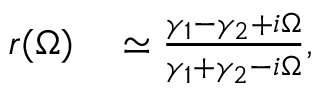Convert formula to latex. <formula><loc_0><loc_0><loc_500><loc_500>\begin{array} { r l } { r ( \Omega ) } & \simeq \frac { \gamma _ { 1 } - \gamma _ { 2 } + i \Omega } { \gamma _ { 1 } + \gamma _ { 2 } - i \Omega } , } \end{array}</formula> 